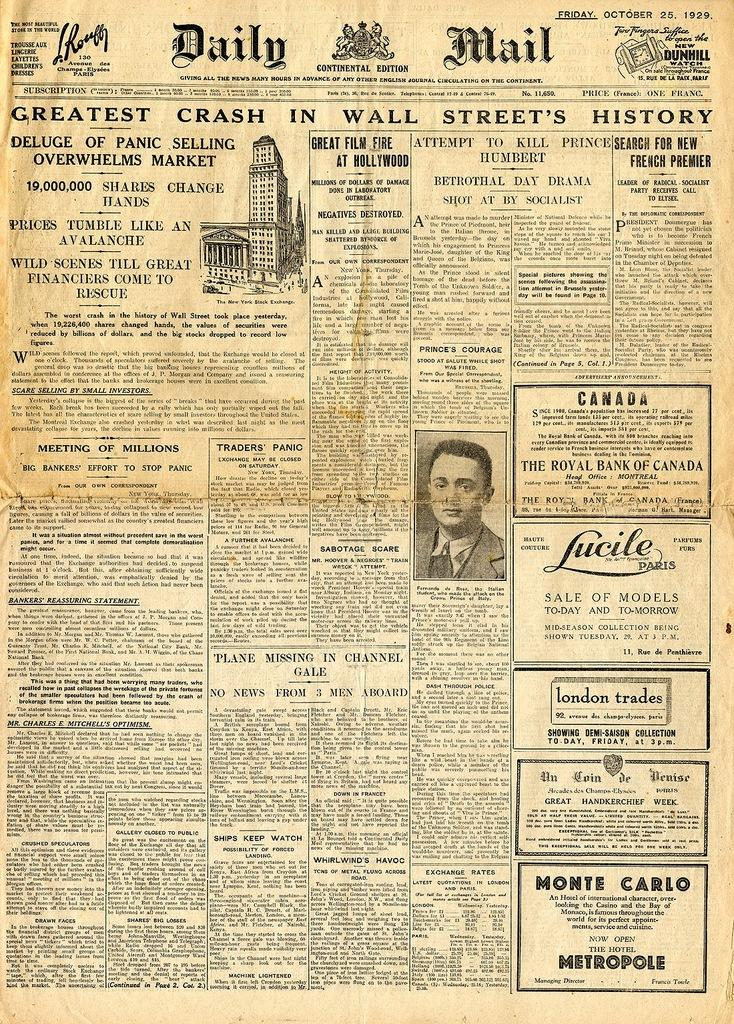What is the main subject of the paper in the image? The paper contains an image of a person and a drawing of a building. What type of content is present on the paper? There is text on the paper. What type of coal is used to create the frame around the image on the paper? There is no frame or coal present in the image; the paper contains an image of a person and a drawing of a building with text. How many twigs are visible in the image? There are no twigs present in the image. 